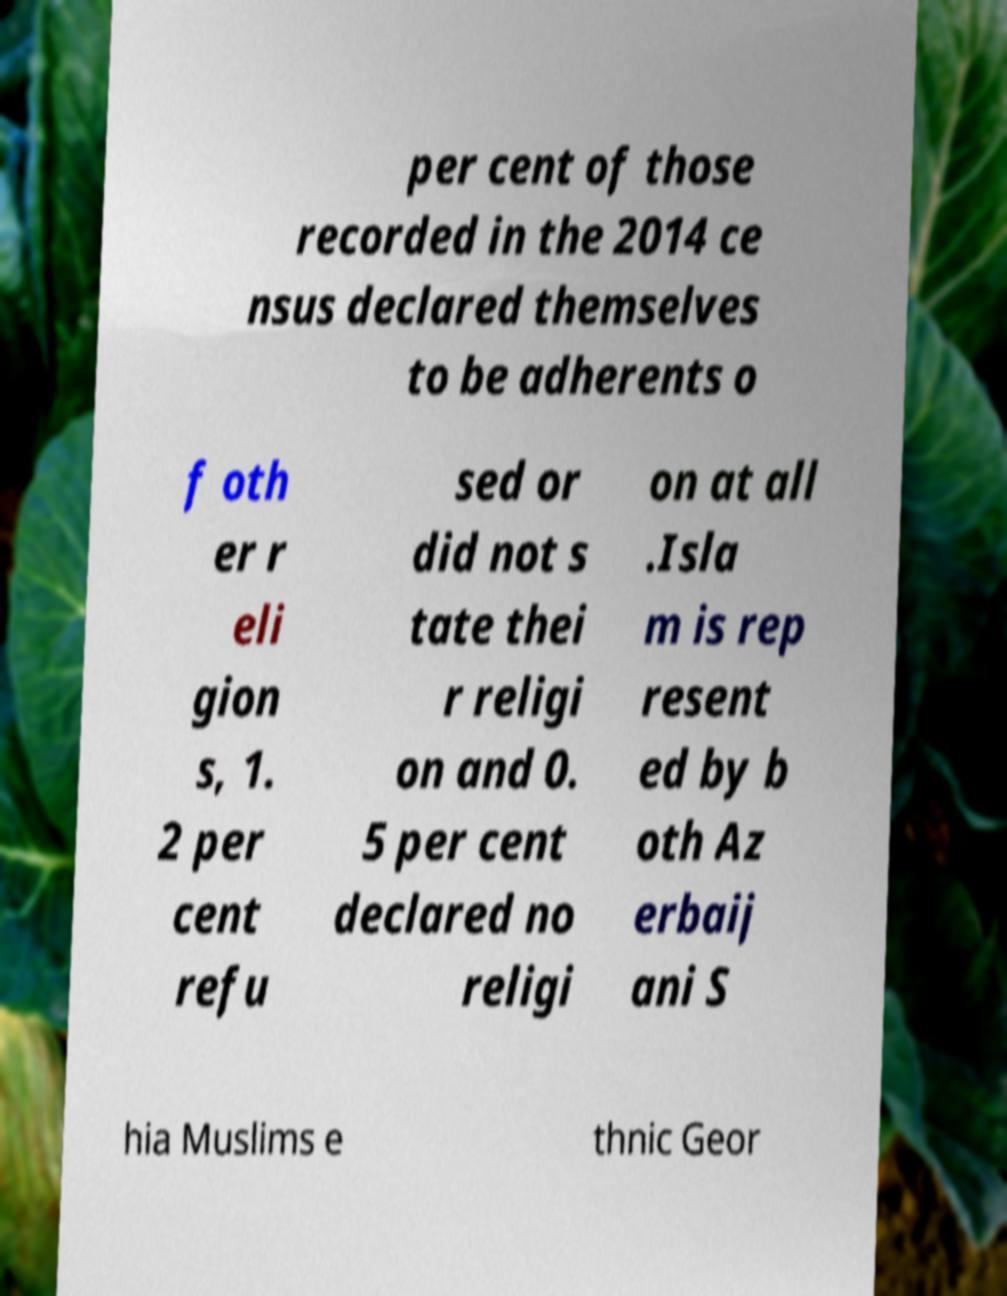Please identify and transcribe the text found in this image. per cent of those recorded in the 2014 ce nsus declared themselves to be adherents o f oth er r eli gion s, 1. 2 per cent refu sed or did not s tate thei r religi on and 0. 5 per cent declared no religi on at all .Isla m is rep resent ed by b oth Az erbaij ani S hia Muslims e thnic Geor 